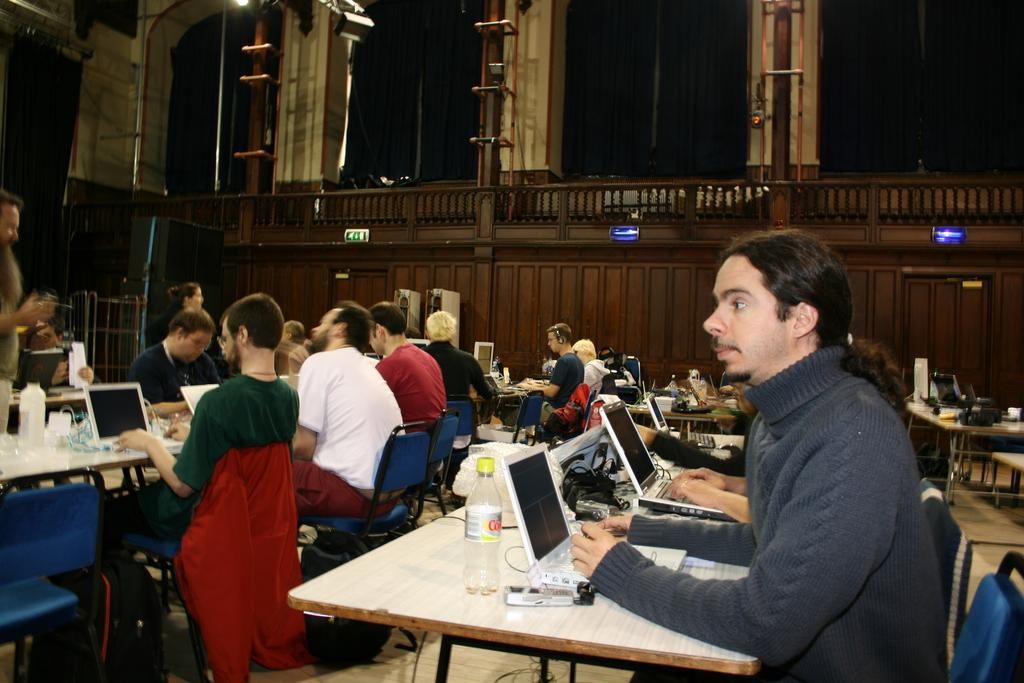How many people are in the image? There is a group of people in the image. What are the people doing in the image? The people are sitting on chairs. What is on the table in the image? There is a laptop and other objects on the table. What is the purpose of the pillar in the image? The purpose of the pillar in the image is not clear from the provided facts. What type of toothpaste is being used by the people in the image? There is no toothpaste present in the image. Can you describe the snakes that are slithering on the table in the image? There are no snakes present in the image. 